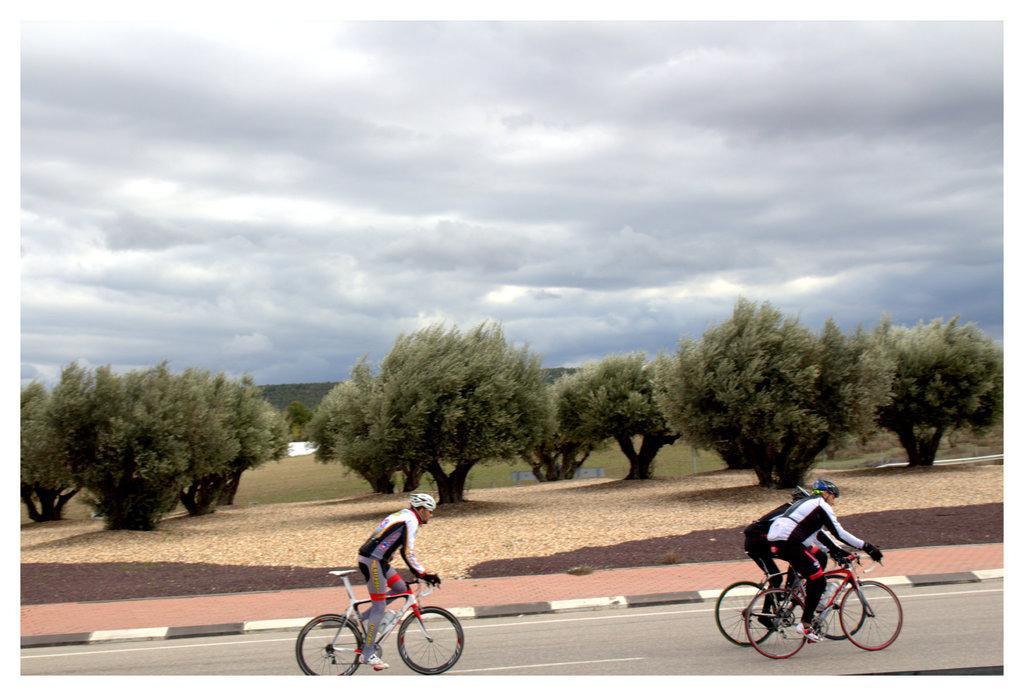How would you summarize this image in a sentence or two? In this image I can see a road in the front and on it I can see few bicycles. I can also see few people on these bicycles. In the background I can see number of trees, cloud and the sky. In the front I can see these people are wearing helmets, gloves and shoes. 